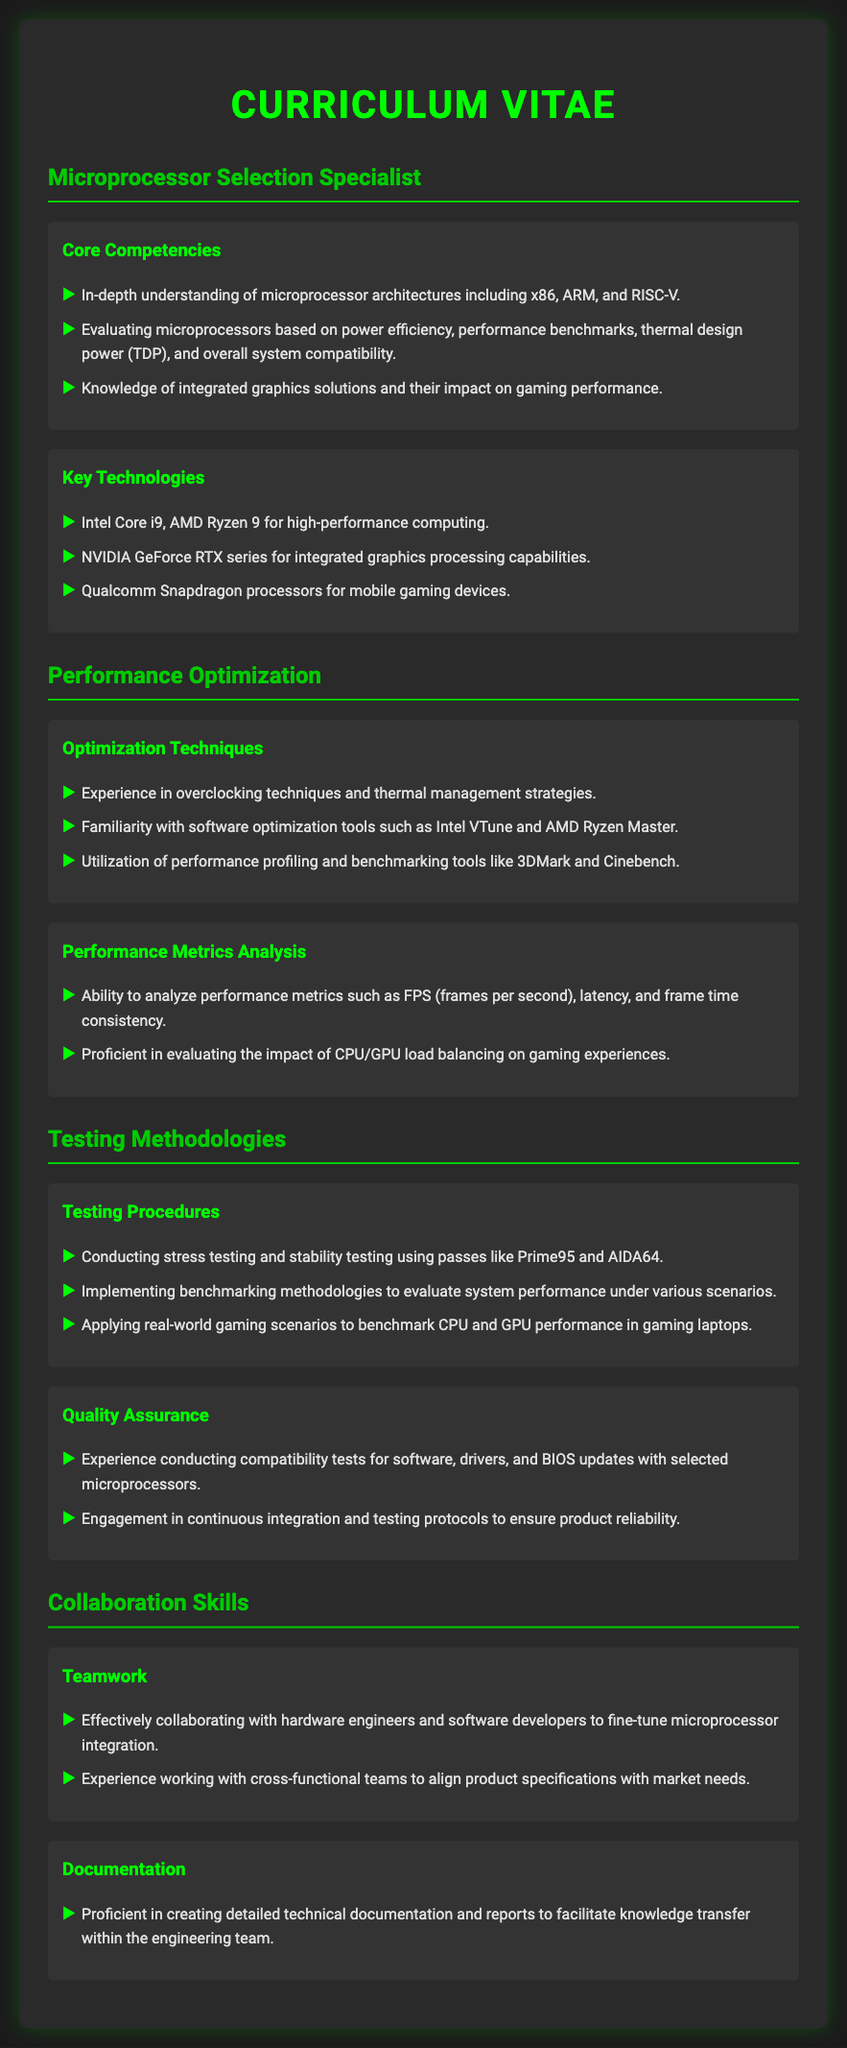What is the title of the CV? The title of the CV is stated prominently at the top of the document.
Answer: Microprocessor Selection Specialist What is one of the key technologies mentioned? The document lists several key technologies related to microprocessors, and one is highlighted for its relevance in high-performance computing.
Answer: Intel Core i9 Which performance optimization tool is mentioned? The document lists software optimization tools, and one is specifically named as a key tool for performance analysis.
Answer: Intel VTune What processor architecture is NOT mentioned in the core competencies? The document specifies various architectures under core competencies, and one is notably absent in the list.
Answer: PowerPC What benchmarking tool is used for performance profiling? The document includes tools used for benchmarking and performance analysis in the optimization techniques section.
Answer: 3DMark How many optimization techniques are listed? The document specifies the optimization techniques, and counting them provides the answer.
Answer: Three What type of testing methodologies are described? The document covers a specific area of testing, detailing the procedures that are part of that methodology.
Answer: Stress testing Which metric is analyzed in performance metrics analysis? The document indicates various performance metrics, with one specific metric being noted in the analysis section.
Answer: FPS What section details collaboration skills? The document includes multiple sections, one of which focuses specifically on teamwork capabilities relevant to working in a project environment.
Answer: Collaboration Skills 